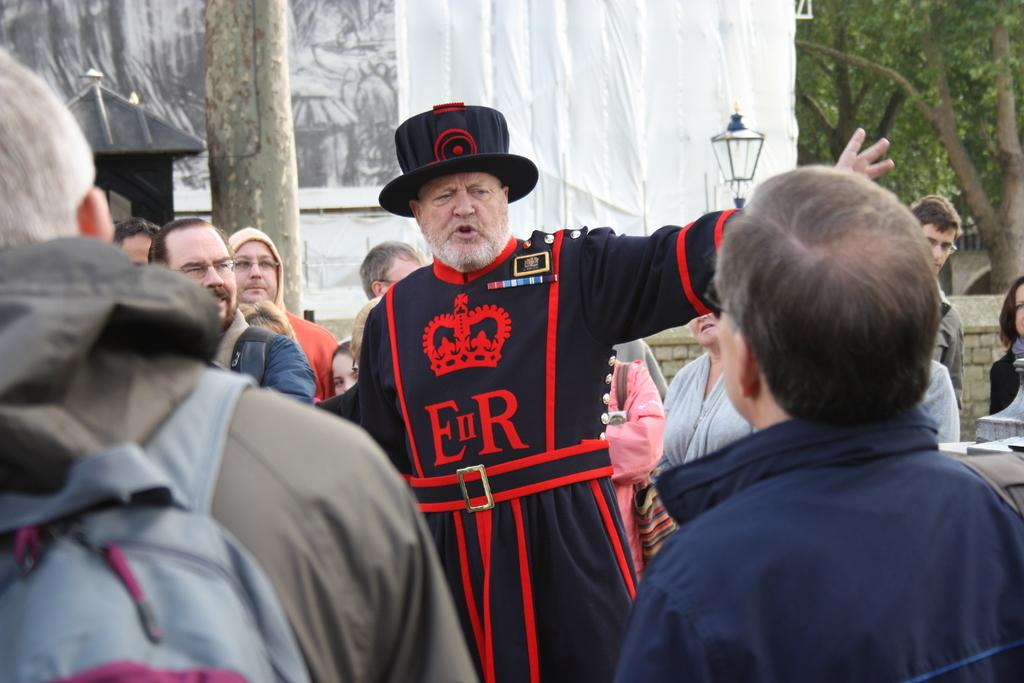What are the people in the image doing? The persons in the image are standing in a group. What can be seen in the background of the image? There are trees, lamps, and a wall in the background of the image. What type of sea creatures can be seen swimming in the image? There is no sea or sea creatures present in the image. What statement is being made by the group of people in the image? The image does not provide any information about a statement being made by the group of people. 